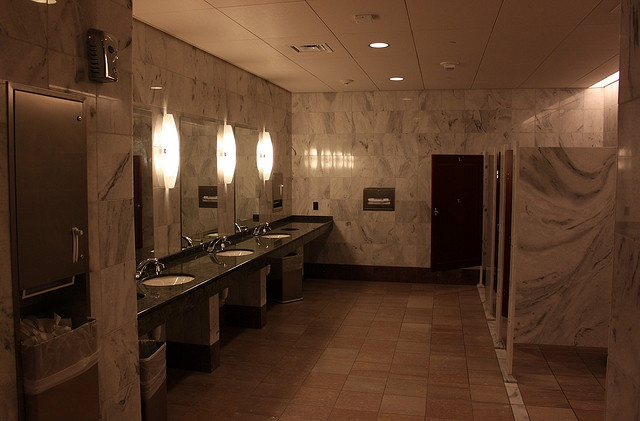Describe the objects in this image and their specific colors. I can see sink in maroon, gray, tan, and black tones, sink in maroon, tan, black, and gray tones, and sink in maroon, black, tan, and gray tones in this image. 